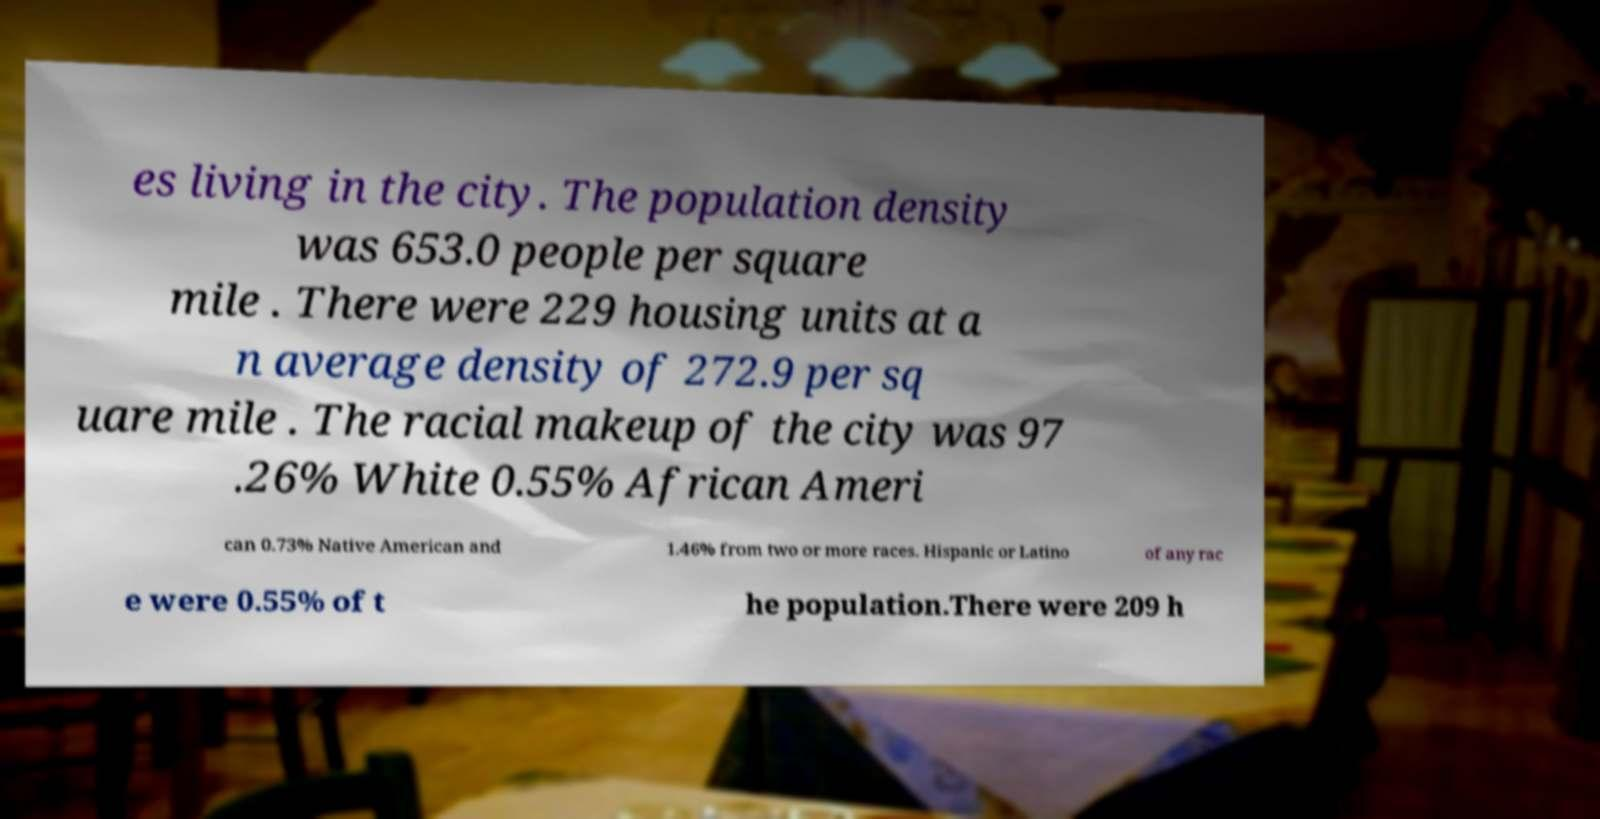Please read and relay the text visible in this image. What does it say? es living in the city. The population density was 653.0 people per square mile . There were 229 housing units at a n average density of 272.9 per sq uare mile . The racial makeup of the city was 97 .26% White 0.55% African Ameri can 0.73% Native American and 1.46% from two or more races. Hispanic or Latino of any rac e were 0.55% of t he population.There were 209 h 